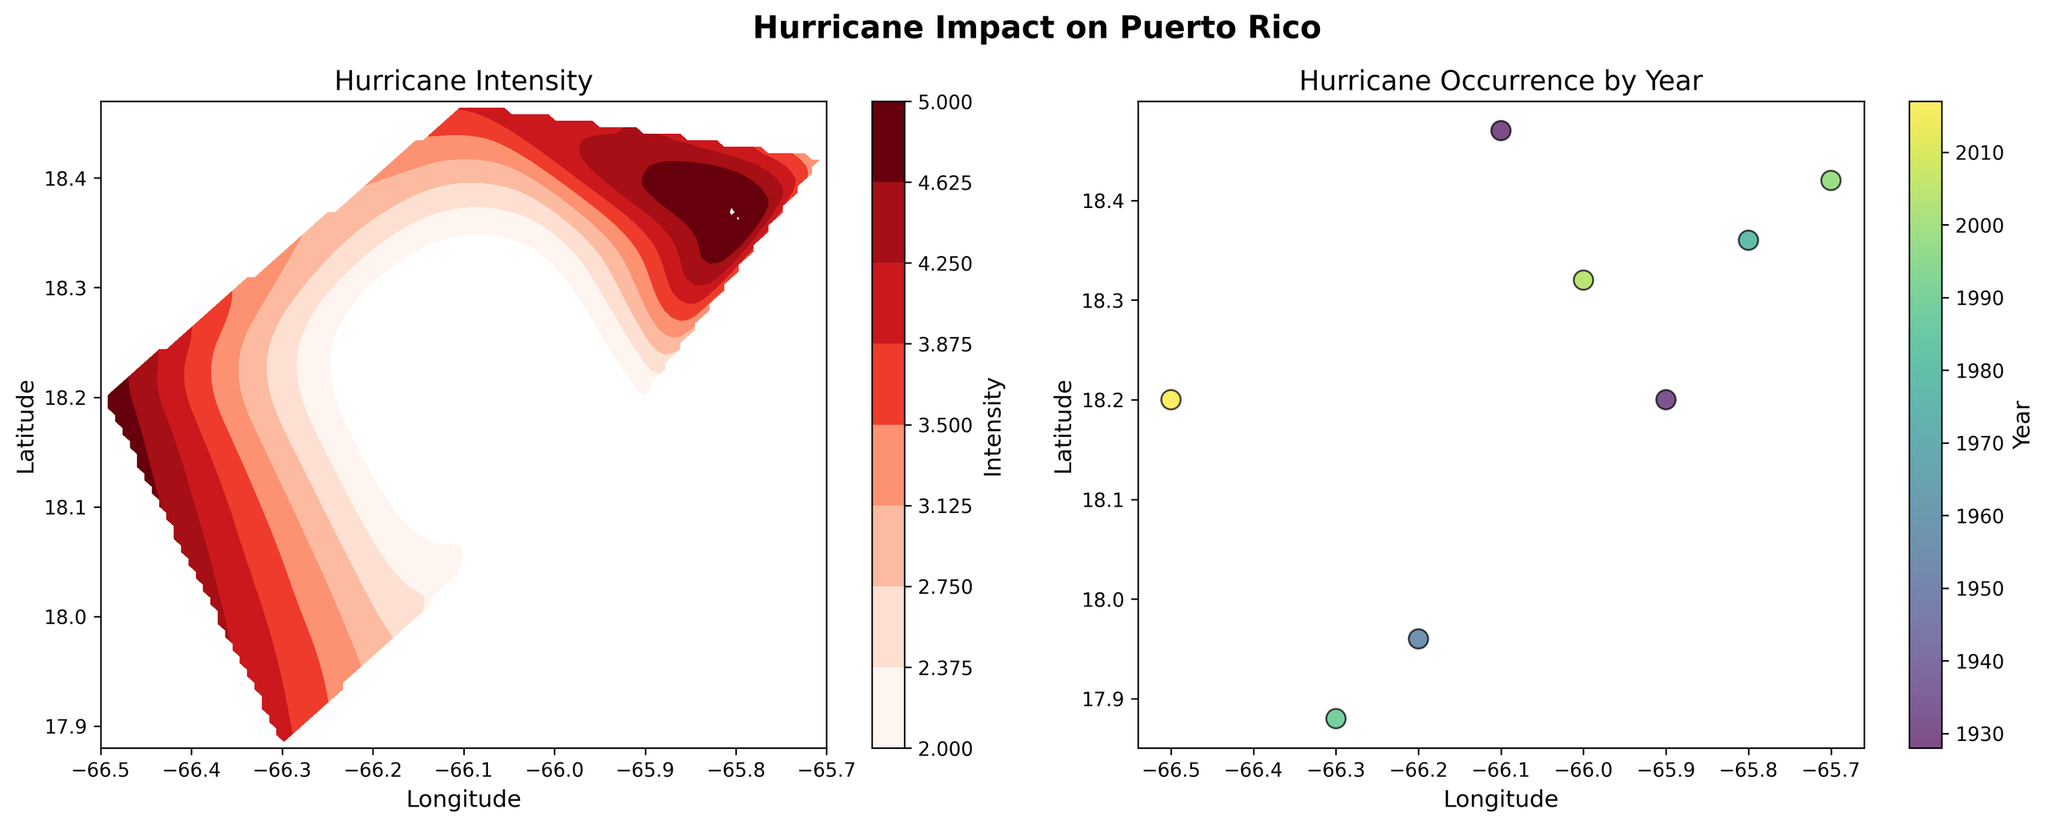How many hurricanes are shown on the scatter plot? The scatter plot shows each hurricane as a separate point. By counting these points, we see there are 8 points, representing 8 hurricanes.
Answer: 8 What is the title of the left subplot? The title is prominently displayed at the top of the left subplot. It reads, "Hurricane Intensity".
Answer: Hurricane Intensity Which hurricane had the highest intensity? The left subplot's contour plot uses colors to indicate intensity levels. The most intense hurricane will be in the deepest color, noted on the color bar as Category 5. The year of the most intense hurricane can be checked in the scatter plot. Both subplots suggest the hurricanes from 1979 and 2017 had the highest intensity, marked as Category 5.
Answer: Hurricanes in 1979 and 2017 What is the range of years for the hurricanes shown in the scatter plot? The scatter plot uses color to represent different years. By looking at the color bar on the right subplot, the earliest and latest years are displayed, showing a range from 1928 to 2017.
Answer: 1928 to 2017 Which hurricane path is furthest south? By examining the latitude (y-axis) values in the scatter plot, the point at the lowest latitude indicates the southernmost hurricane. The lowest latitude is approximately 17.88, corresponding to the hurricane in 1989.
Answer: 1989 Were there more hurricanes with an intensity of 3 or more before or after 1960? Check the scatter plot to identify which years correspond to higher intensities. Hurricanes with intensity of 3 or more occurred in 1956, 1979, 1989, 1998, and 2017. Count the number of points before and after 1960 to compare. Four hurricanes are post-1960, and one is pre-1960.
Answer: After 1960 Which subplot would help you understand the spatial distribution of hurricane intensity better? The contour plot on the left shows the spatial intensity distribution using a color gradient, while the scatter plot on the right only shows individual data points by location and year. Therefore, the contour plot provides a clearer spatial distribution of intensity.
Answer: The left subplot (contour plot) What can you infer about the relationship between hurricane intensity and their geographical paths over Puerto Rico? Observing the contour levels in the left subplot, it's evident that high-intensity levels (darker colors) are concentrated in specific areas, suggesting that certain paths were more prone to severe hurricanes. The scatter plot indicates if these high-intensity paths correlates with specific years.
Answer: High-intensity hurricanes follow specific paths Is there a significant clustering of hurricanes in specific years or are they evenly spread out? By observing the color spread in the scatter plot, we see that hurricanes are not evenly spread but have clusters in certain years, particularly around the years 1956, 1979, 1989, and 2017.
Answer: Clustering in specific years 